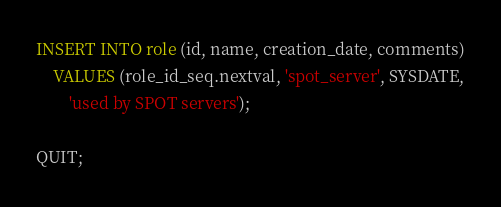<code> <loc_0><loc_0><loc_500><loc_500><_SQL_>INSERT INTO role (id, name, creation_date, comments)
	VALUES (role_id_seq.nextval, 'spot_server', SYSDATE,
		'used by SPOT servers');

QUIT;
</code> 